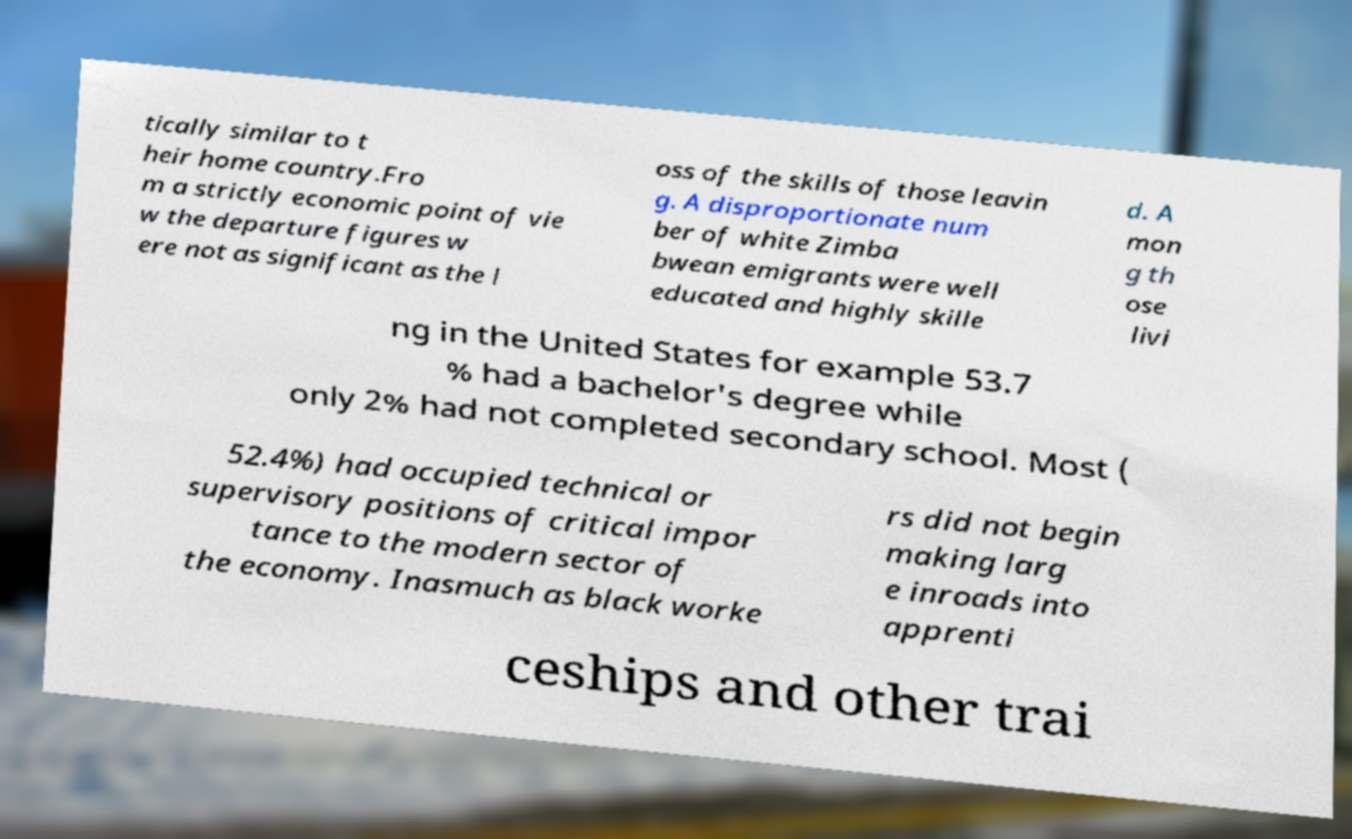What messages or text are displayed in this image? I need them in a readable, typed format. tically similar to t heir home country.Fro m a strictly economic point of vie w the departure figures w ere not as significant as the l oss of the skills of those leavin g. A disproportionate num ber of white Zimba bwean emigrants were well educated and highly skille d. A mon g th ose livi ng in the United States for example 53.7 % had a bachelor's degree while only 2% had not completed secondary school. Most ( 52.4%) had occupied technical or supervisory positions of critical impor tance to the modern sector of the economy. Inasmuch as black worke rs did not begin making larg e inroads into apprenti ceships and other trai 